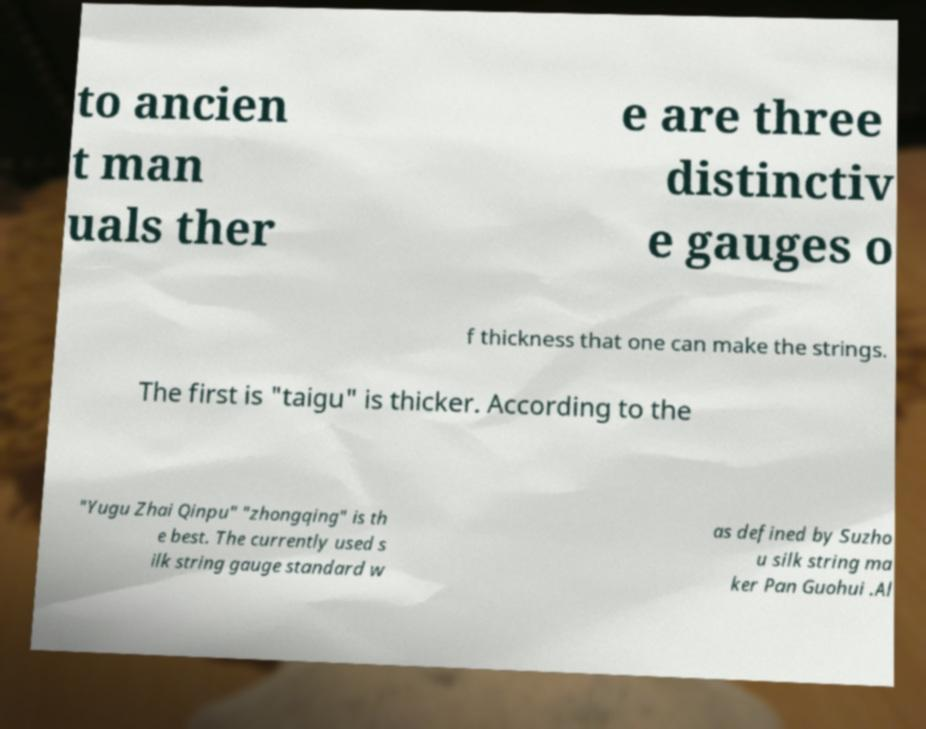Please identify and transcribe the text found in this image. to ancien t man uals ther e are three distinctiv e gauges o f thickness that one can make the strings. The first is "taigu" is thicker. According to the "Yugu Zhai Qinpu" "zhongqing" is th e best. The currently used s ilk string gauge standard w as defined by Suzho u silk string ma ker Pan Guohui .Al 